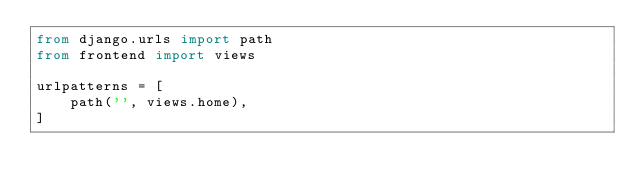Convert code to text. <code><loc_0><loc_0><loc_500><loc_500><_Python_>from django.urls import path
from frontend import views

urlpatterns = [
    path('', views.home),
]
</code> 